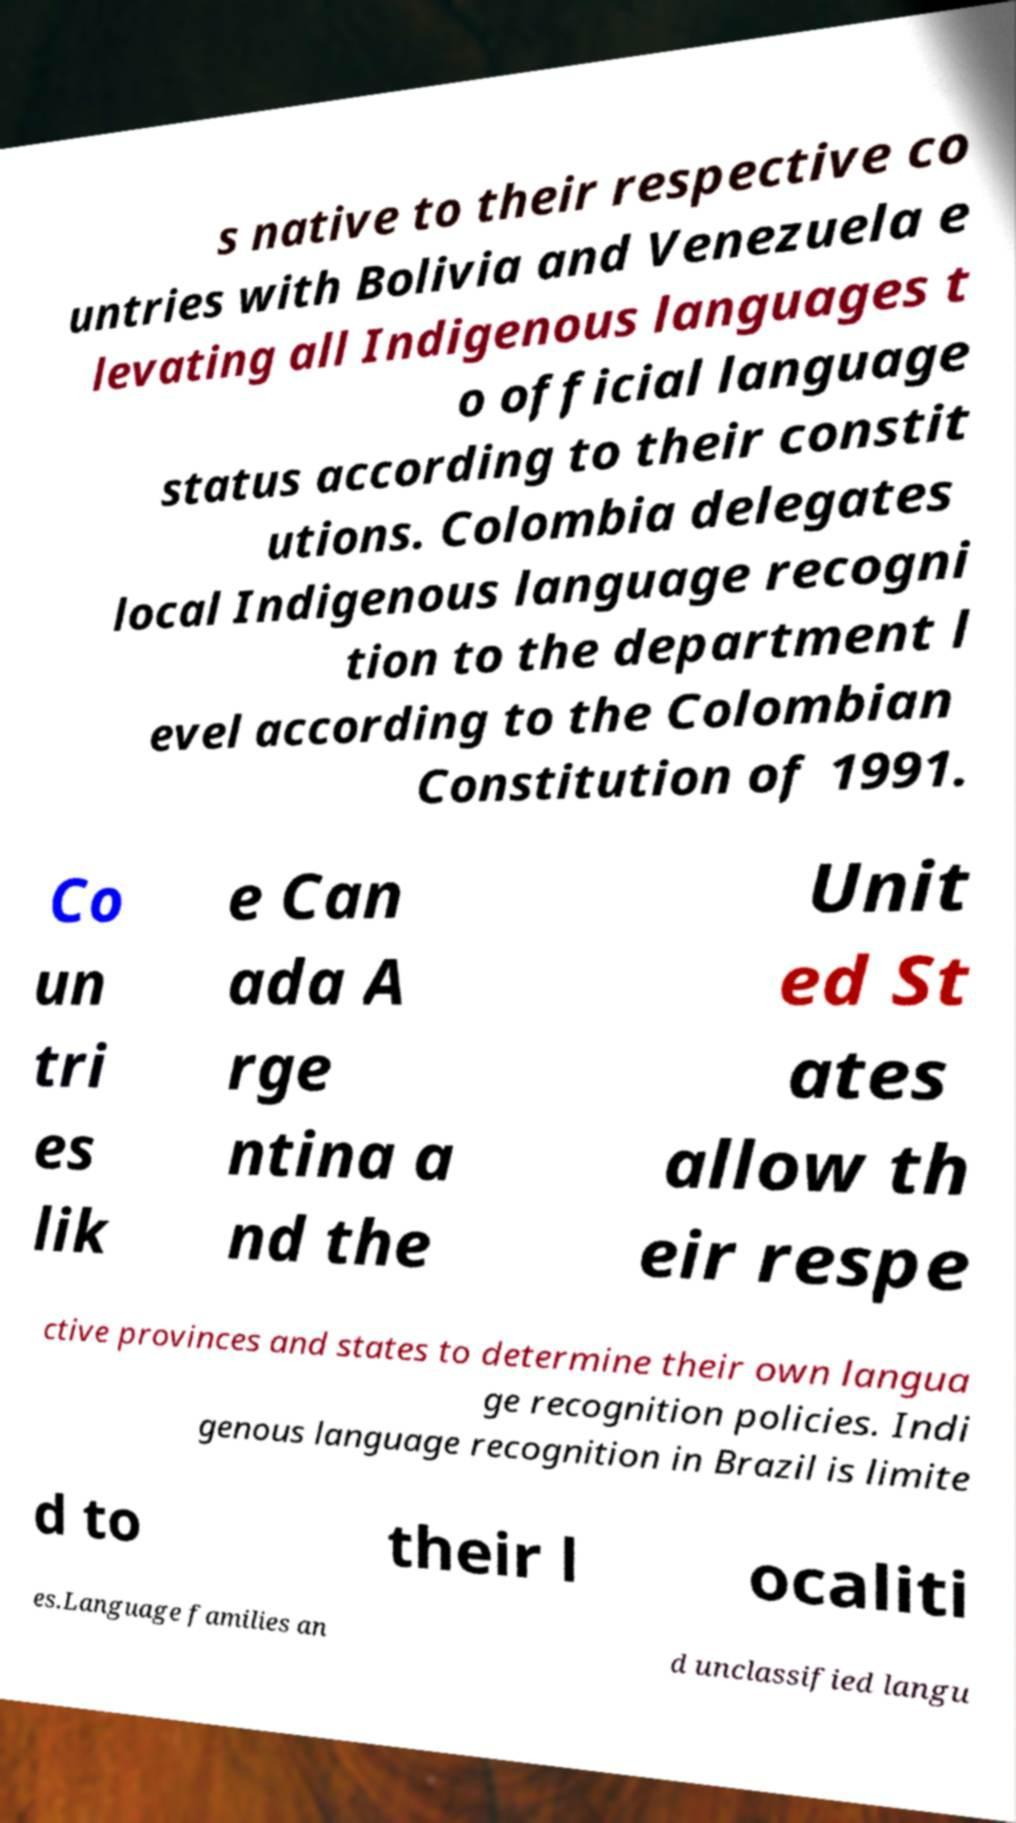Could you assist in decoding the text presented in this image and type it out clearly? s native to their respective co untries with Bolivia and Venezuela e levating all Indigenous languages t o official language status according to their constit utions. Colombia delegates local Indigenous language recogni tion to the department l evel according to the Colombian Constitution of 1991. Co un tri es lik e Can ada A rge ntina a nd the Unit ed St ates allow th eir respe ctive provinces and states to determine their own langua ge recognition policies. Indi genous language recognition in Brazil is limite d to their l ocaliti es.Language families an d unclassified langu 